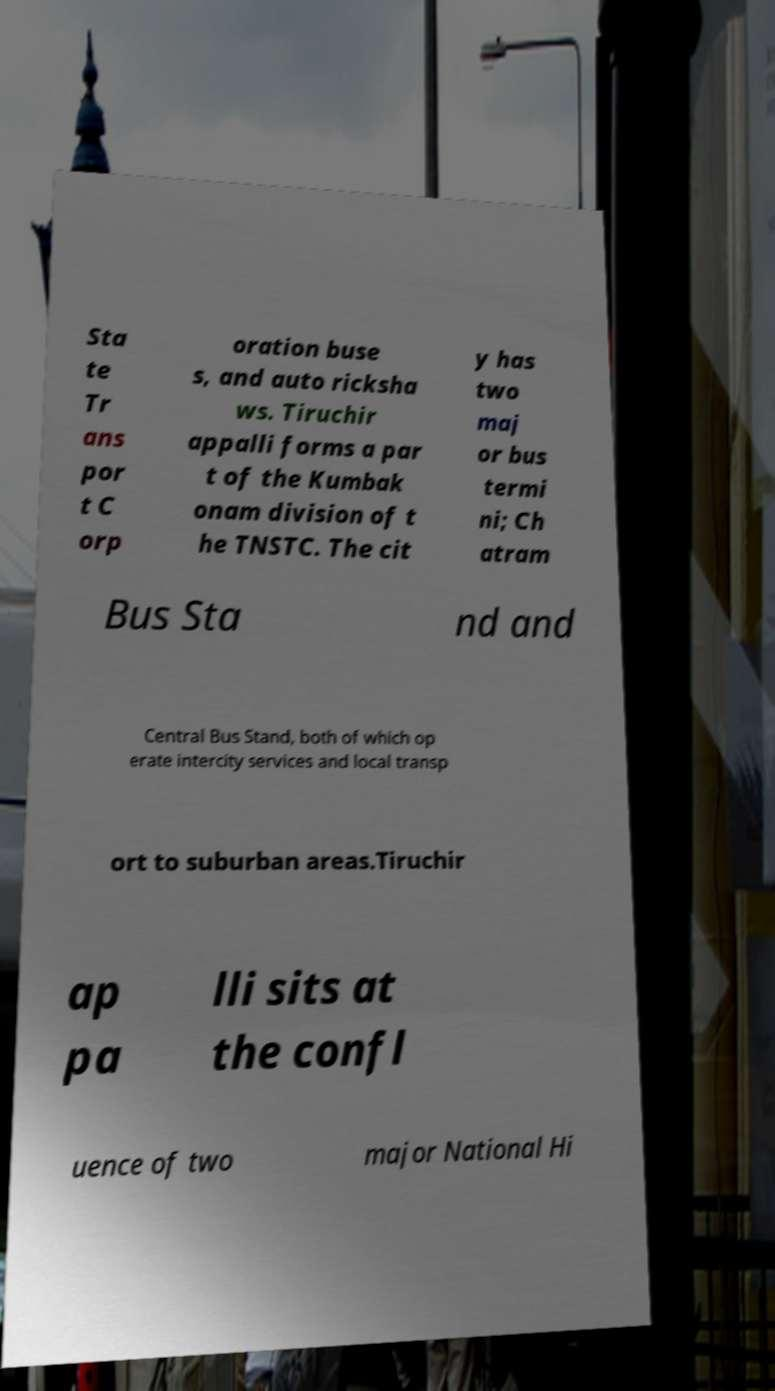There's text embedded in this image that I need extracted. Can you transcribe it verbatim? Sta te Tr ans por t C orp oration buse s, and auto ricksha ws. Tiruchir appalli forms a par t of the Kumbak onam division of t he TNSTC. The cit y has two maj or bus termi ni; Ch atram Bus Sta nd and Central Bus Stand, both of which op erate intercity services and local transp ort to suburban areas.Tiruchir ap pa lli sits at the confl uence of two major National Hi 